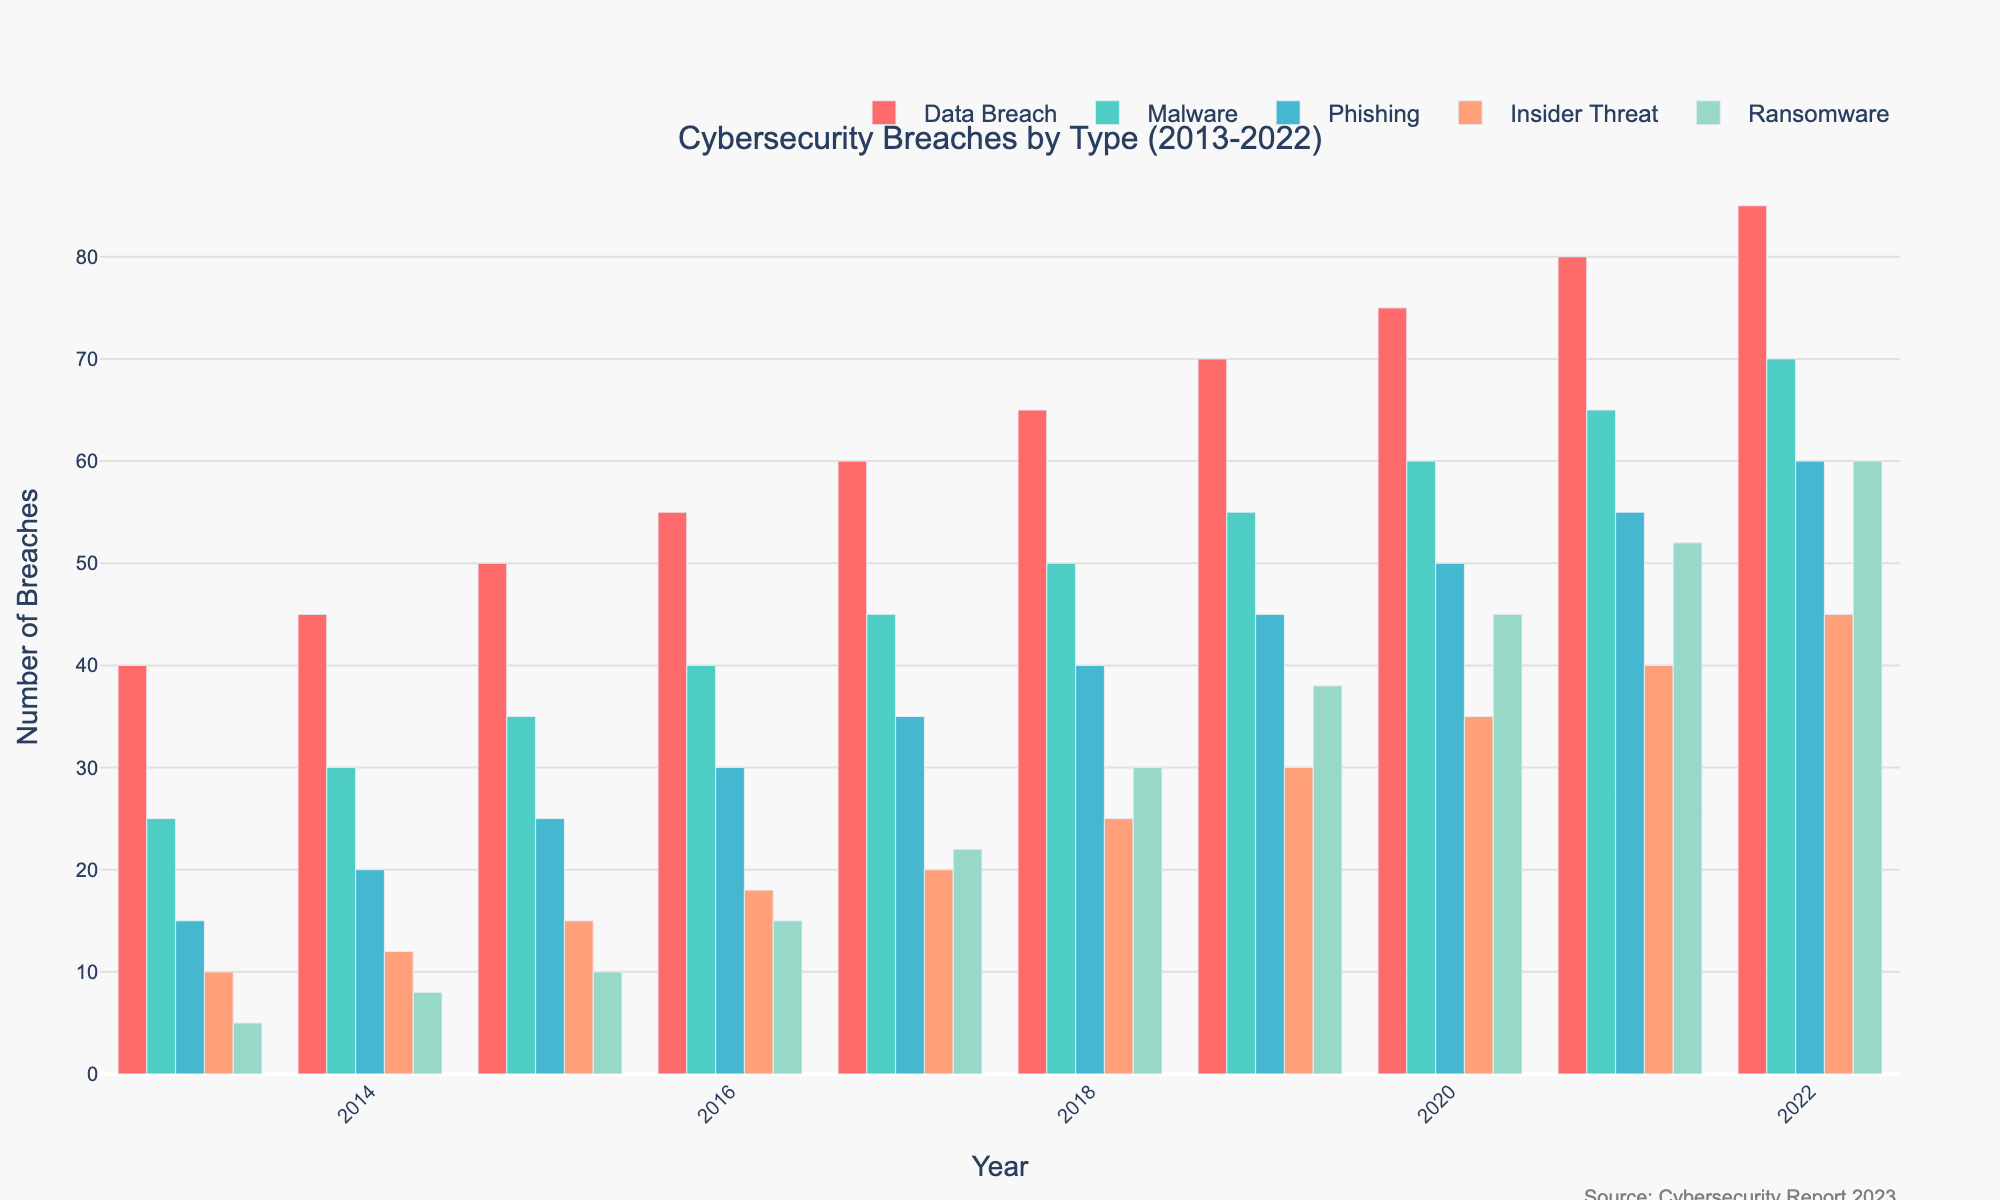Which year had the highest total number of reported breaches? By looking at the heights of the bars, the highest total number of breaches can be observed in 2022. Specifically, each category of breaches in 2022 has higher or comparable values than previous years.
Answer: 2022 Which type of breach showed the most significant increase from 2013 to 2022? To find the type of breach with the most significant increase, we compare the heights of the bars across these years. Ransomware breaches increased from 5 in 2013 to 60 in 2022, which is a significant increment compared to other types.
Answer: Ransomware How many more Data Breaches were there in 2022 compared to 2015? To find the difference, subtract the number of Data Breaches in 2015 from that in 2022: 85 (2022) - 50 (2015) = 35.
Answer: 35 What is the average number of Malware breaches reported from 2013 to 2022? To find the average, sum up the number of Malware breaches over the years and divide by the number of years: (25+ 30+ 35+ 40+ 45+ 50+ 55+ 60+ 65+ 70) / 10 = 47.5.
Answer: 47.5 Which breach type had the least variations in numbers over the years? By visually comparing the bar heights across years, Insider Threat shows the least variation as the heights remain relatively close over the years compared to other types.
Answer: Insider Threat Was there any year where Phishing attacks were exactly the same as the year before? By comparing the bar heights for Phishing, all years show an increase in breaches compared to the previous year, so no year had the same number of Phishing attacks as the previous
Answer: No Which two types of breaches had an equal number of incidents reported in any year? By looking at the bar heights across years, Malware and Data Breaches had equal numbers in no specific year; and the same goes for any other comparison.
Answer: None How do the total breaches in 2020 compare to those in 2018 across all types? Sum the breaches for each year and compare: 2020 total = 75+60+50+35+45 = 265; 2018 total = 65+50+40+25+30 = 210. The difference is 265 - 210 = 55.
Answer: 2020 > 2018 by 55 